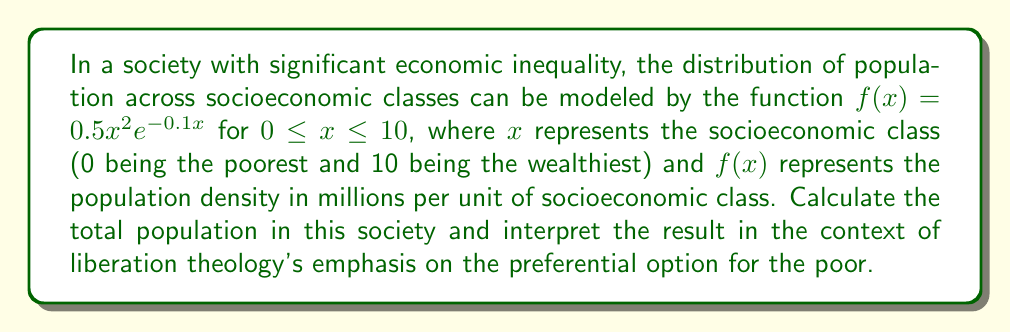Help me with this question. To solve this problem, we need to compute the area under the curve of $f(x) = 0.5x^2e^{-0.1x}$ from $x = 0$ to $x = 10$. This can be done using definite integration.

Step 1: Set up the definite integral
$$\int_0^{10} 0.5x^2e^{-0.1x} dx$$

Step 2: This integral cannot be solved using elementary antiderivatives. We need to use numerical integration methods. Let's use Simpson's Rule with 10 subintervals for a good approximation.

Simpson's Rule formula:
$$\int_a^b f(x)dx \approx \frac{h}{3}[f(x_0) + 4f(x_1) + 2f(x_2) + 4f(x_3) + ... + 2f(x_{n-2}) + 4f(x_{n-1}) + f(x_n)]$$

where $h = \frac{b-a}{n}$, $n$ is the number of subintervals (even), and $x_i = a + ih$

Step 3: Calculate $h$ and the $x_i$ values
$h = \frac{10-0}{10} = 1$
$x_i = 0, 1, 2, ..., 10$

Step 4: Calculate $f(x_i)$ for each $x_i$
$f(0) = 0$
$f(1) = 0.5 \cdot 1^2 \cdot e^{-0.1} \approx 0.4524$
$f(2) = 0.5 \cdot 2^2 \cdot e^{-0.2} \approx 1.6374$
...
$f(10) = 0.5 \cdot 10^2 \cdot e^{-1} \approx 18.3940$

Step 5: Apply Simpson's Rule
$$\begin{align*}
\text{Area} &\approx \frac{1}{3}[0 + 4(0.4524) + 2(1.6374) + 4(3.3284) + 2(5.2795) + \\
&\quad 4(7.2910) + 2(9.2419) + 4(11.0656) + 2(12.7329) + 4(14.2435) + 18.3940] \\
&\approx 33.0233
\end{align*}$$

Step 6: Interpret the result
The total population is approximately 33.0233 million. In the context of liberation theology, this result shows the distribution of population across socioeconomic classes, highlighting the need for policies that address inequality and prioritize the needs of the poor and marginalized.
Answer: The total population is approximately 33.0233 million. 